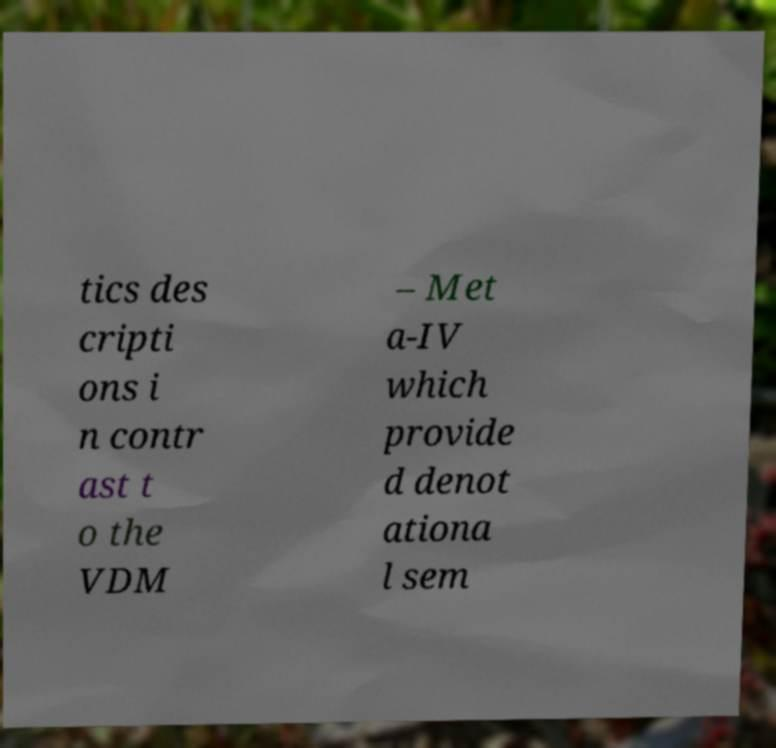Can you accurately transcribe the text from the provided image for me? tics des cripti ons i n contr ast t o the VDM – Met a-IV which provide d denot ationa l sem 